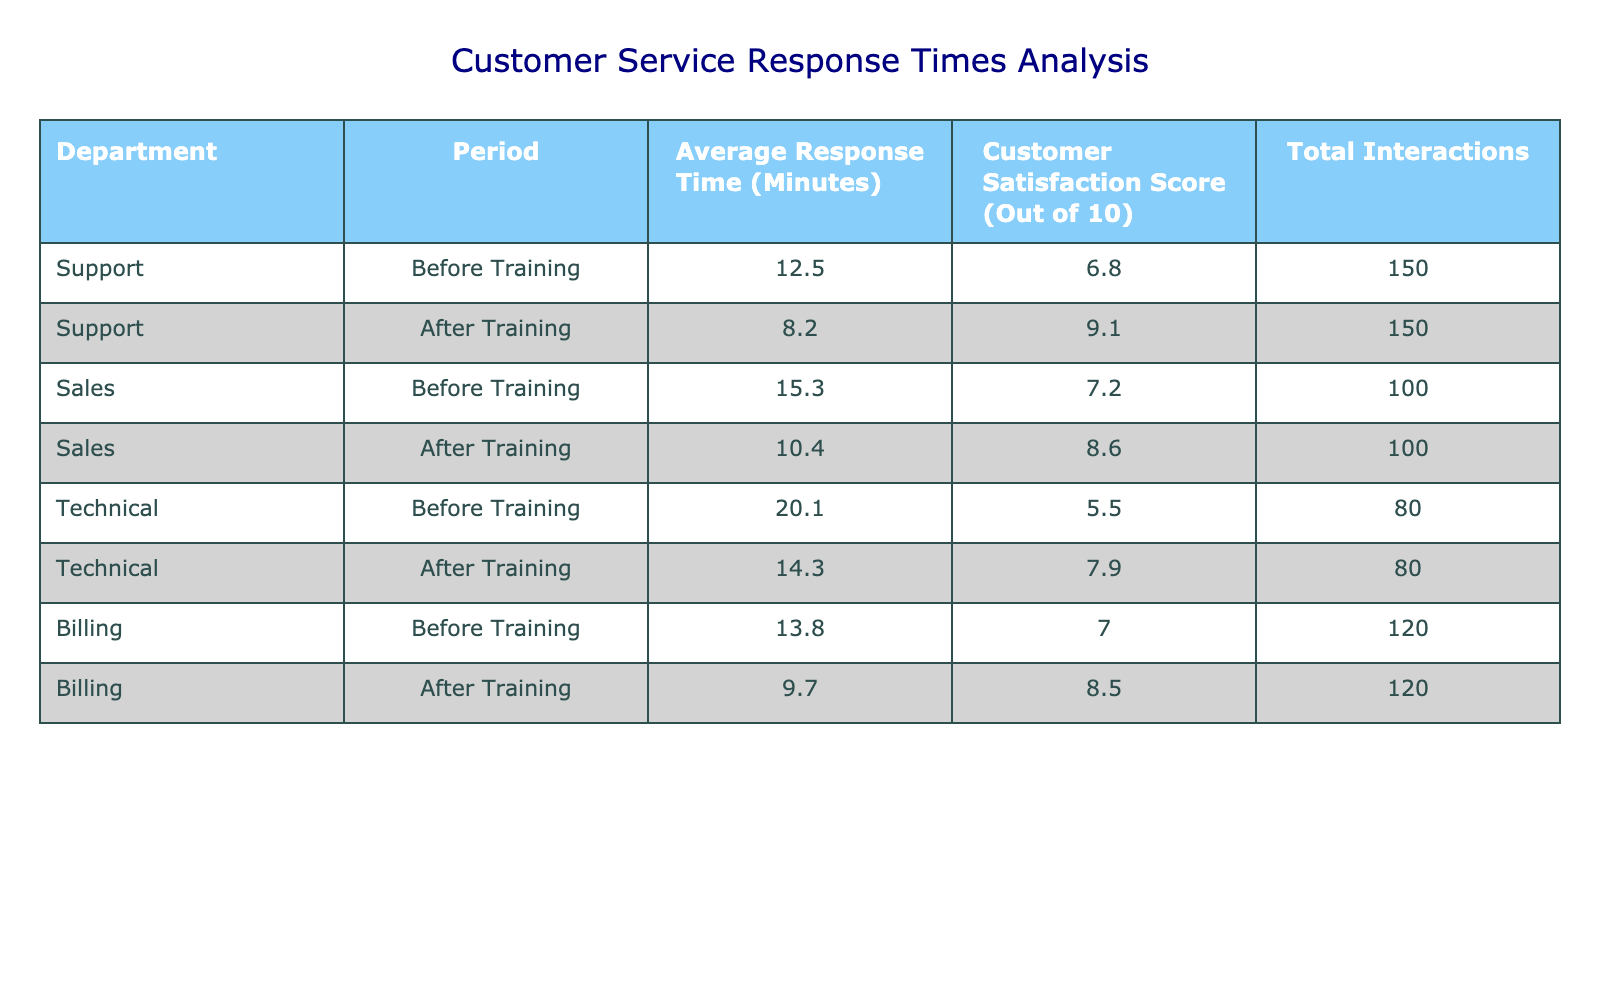What was the average response time for the Support department before the training? According to the table, the average response time for the Support department before the training is listed as 12.5 minutes.
Answer: 12.5 minutes What was the customer satisfaction score for the Sales department after the training? The table shows that the customer satisfaction score for the Sales department after the training was 8.6 out of 10.
Answer: 8.6 out of 10 Which department experienced the greatest reduction in average response time after training? By comparing the average response times, Support department reduced from 12.5 to 8.2 minutes, a decrease of 4.3 minutes. The Technical department reduced from 20.1 to 14.3 minutes, a decrease of 5.8 minutes. Since 5.8 minutes is greater than 4.3 minutes, the Technical department experienced the greatest reduction.
Answer: Technical department Did the average customer satisfaction score improve for all departments after the training? Examining the scores shows that the Support, Sales, and Billing departments all improved, while the Technical department improved from 5.5 to 7.9, which is also an increase. Therefore, yes, all departments saw improvement in customer satisfaction.
Answer: Yes What is the difference in average response time between the Technical department before and after training? The average response time before training was 20.1 minutes and after training it was 14.3 minutes. The difference is calculated as 20.1 - 14.3 = 5.8 minutes.
Answer: 5.8 minutes What is the average customer satisfaction score for all departments after the training? To find the average after training, we sum the scores: 9.1 (Support) + 8.6 (Sales) + 7.9 (Technical) + 8.5 (Billing) = 34.1, and divide by 4 (the number of departments): 34.1 / 4 = 8.525, which can be rounded to 8.5.
Answer: 8.5 Which department had the lowest customer satisfaction score before the training? Looking at the scores before training, the Technical department had the lowest score of 5.5 out of 10.
Answer: Technical department How many total interactions were recorded for the Billing department after the training? The table states that the total interactions for the Billing department after the training remain at 120.
Answer: 120 